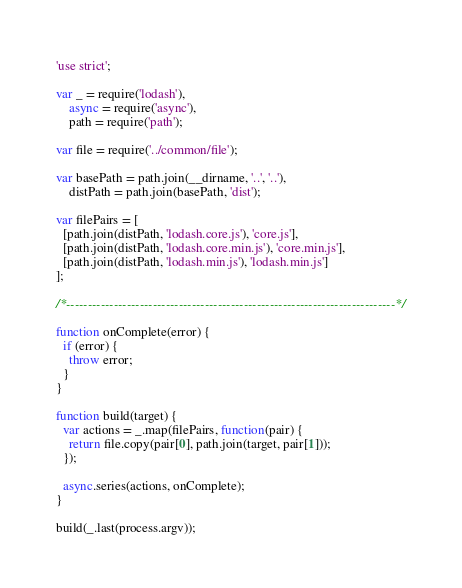<code> <loc_0><loc_0><loc_500><loc_500><_JavaScript_>'use strict';

var _ = require('lodash'),
    async = require('async'),
    path = require('path');

var file = require('../common/file');

var basePath = path.join(__dirname, '..', '..'),
    distPath = path.join(basePath, 'dist');

var filePairs = [
  [path.join(distPath, 'lodash.core.js'), 'core.js'],
  [path.join(distPath, 'lodash.core.min.js'), 'core.min.js'],
  [path.join(distPath, 'lodash.min.js'), 'lodash.min.js']
];

/*----------------------------------------------------------------------------*/

function onComplete(error) {
  if (error) {
    throw error;
  }
}

function build(target) {
  var actions = _.map(filePairs, function(pair) {
    return file.copy(pair[0], path.join(target, pair[1]));
  });

  async.series(actions, onComplete);
}

build(_.last(process.argv));
</code> 